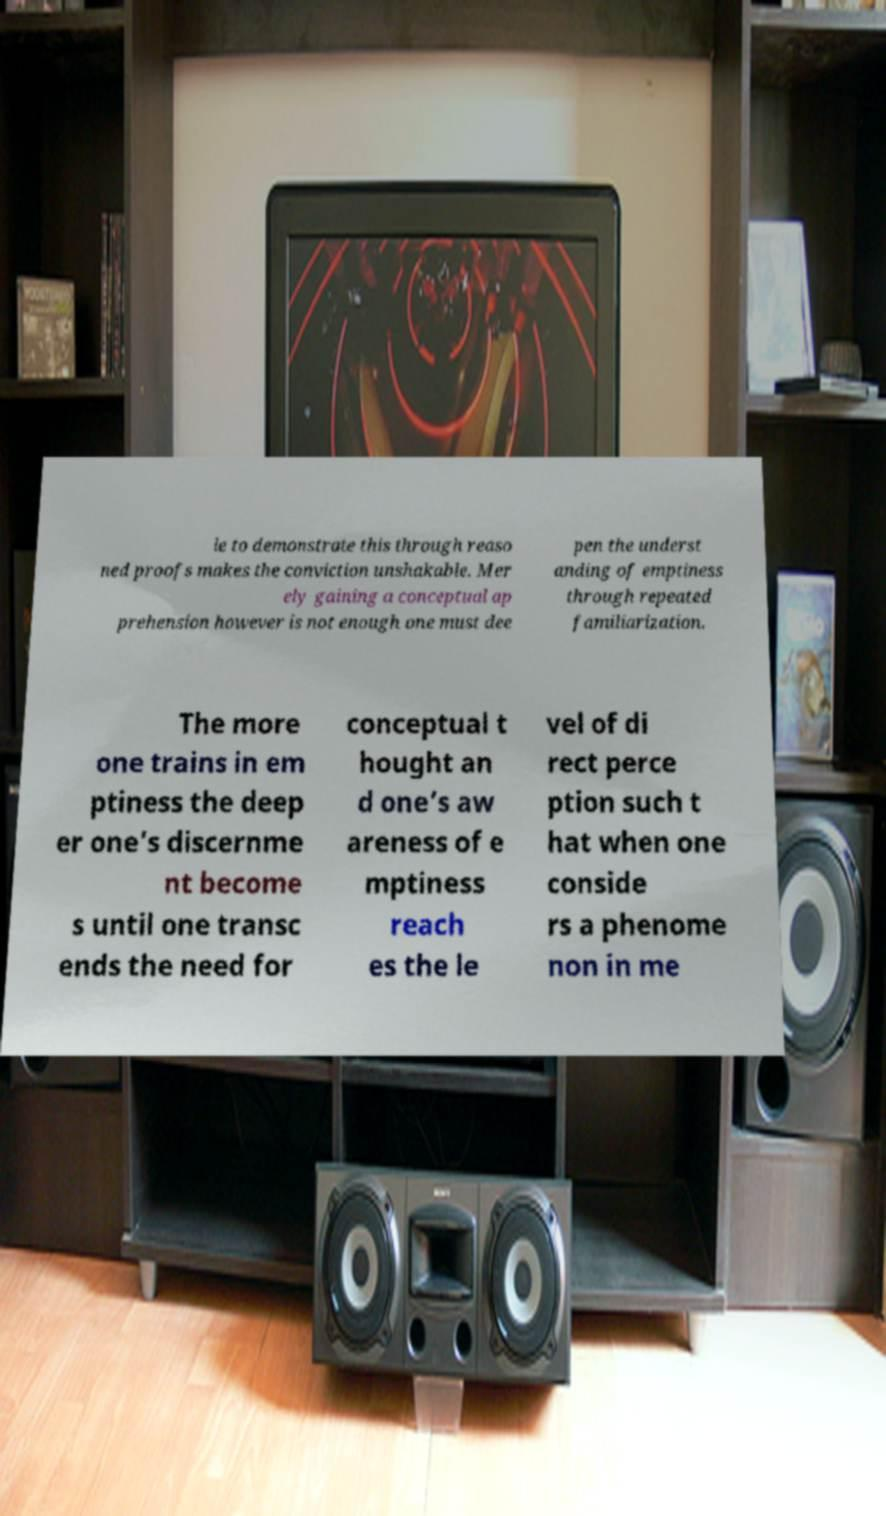Can you read and provide the text displayed in the image?This photo seems to have some interesting text. Can you extract and type it out for me? le to demonstrate this through reaso ned proofs makes the conviction unshakable. Mer ely gaining a conceptual ap prehension however is not enough one must dee pen the underst anding of emptiness through repeated familiarization. The more one trains in em ptiness the deep er one’s discernme nt become s until one transc ends the need for conceptual t hought an d one’s aw areness of e mptiness reach es the le vel of di rect perce ption such t hat when one conside rs a phenome non in me 